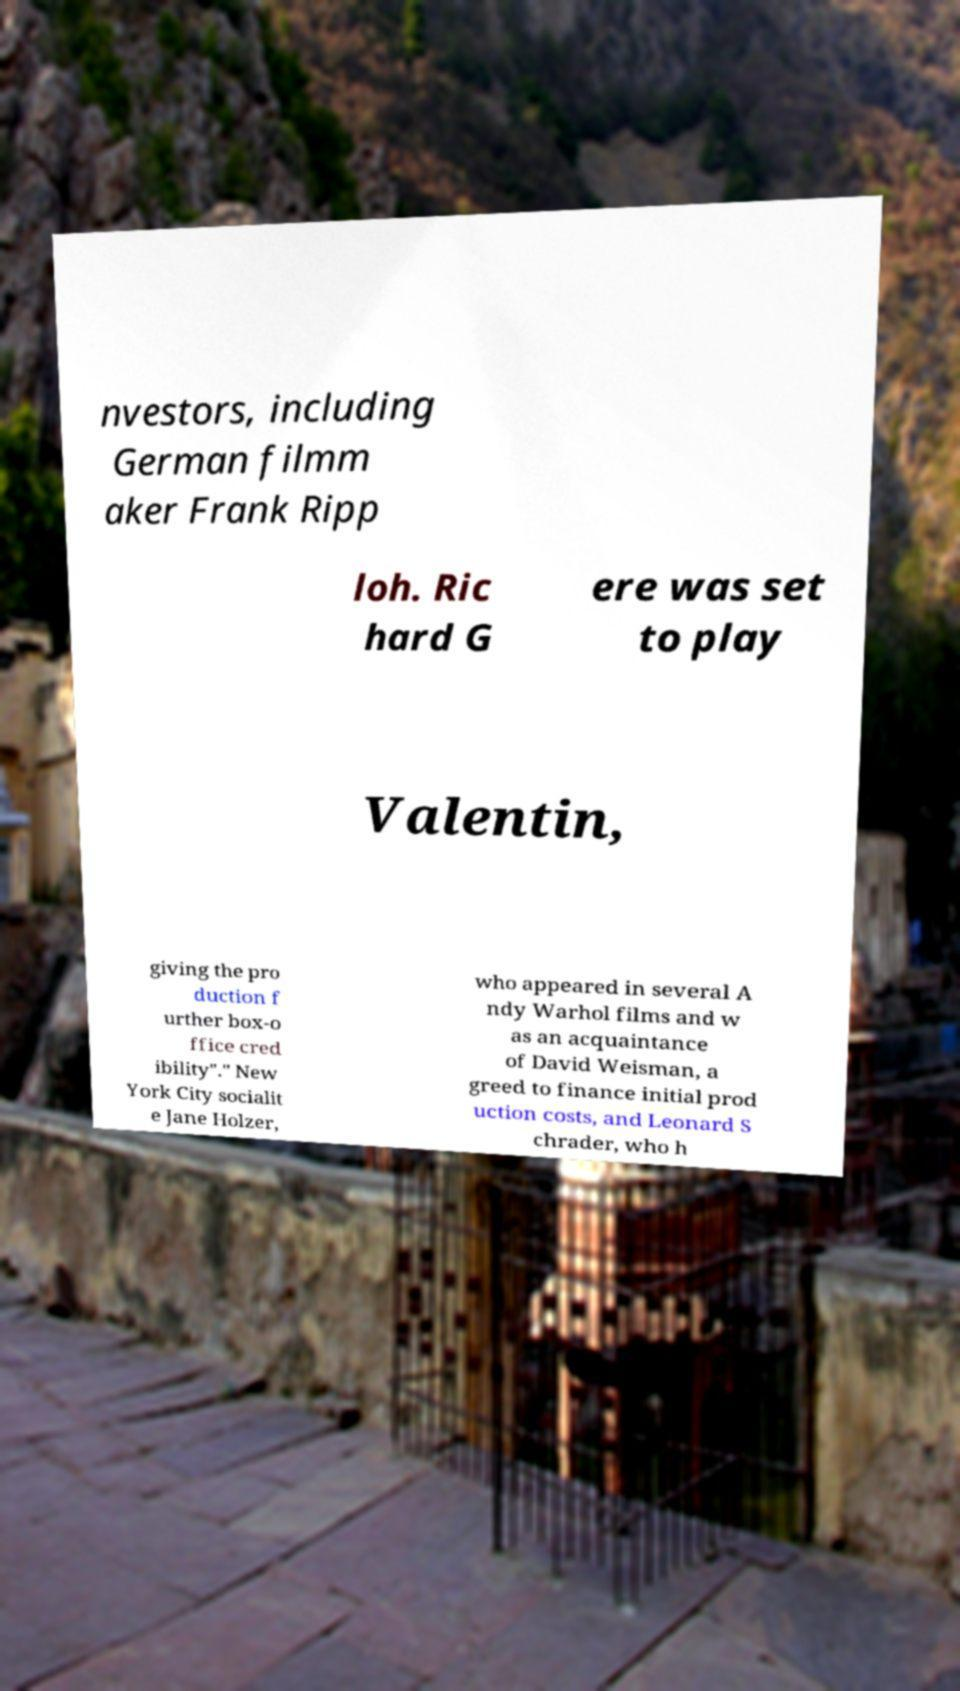Please identify and transcribe the text found in this image. nvestors, including German filmm aker Frank Ripp loh. Ric hard G ere was set to play Valentin, giving the pro duction f urther box-o ffice cred ibility"." New York City socialit e Jane Holzer, who appeared in several A ndy Warhol films and w as an acquaintance of David Weisman, a greed to finance initial prod uction costs, and Leonard S chrader, who h 